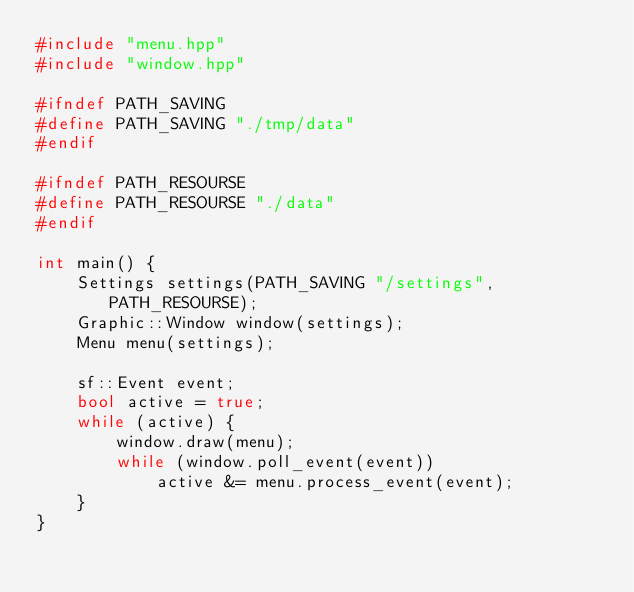<code> <loc_0><loc_0><loc_500><loc_500><_C++_>#include "menu.hpp"
#include "window.hpp"

#ifndef PATH_SAVING
#define PATH_SAVING "./tmp/data"
#endif

#ifndef PATH_RESOURSE
#define PATH_RESOURSE "./data"
#endif

int main() {
	Settings settings(PATH_SAVING "/settings", PATH_RESOURSE);
	Graphic::Window window(settings);
	Menu menu(settings);

	sf::Event event;
	bool active = true;
	while (active) {
		window.draw(menu);
		while (window.poll_event(event))
			active &= menu.process_event(event);
	}
}
</code> 